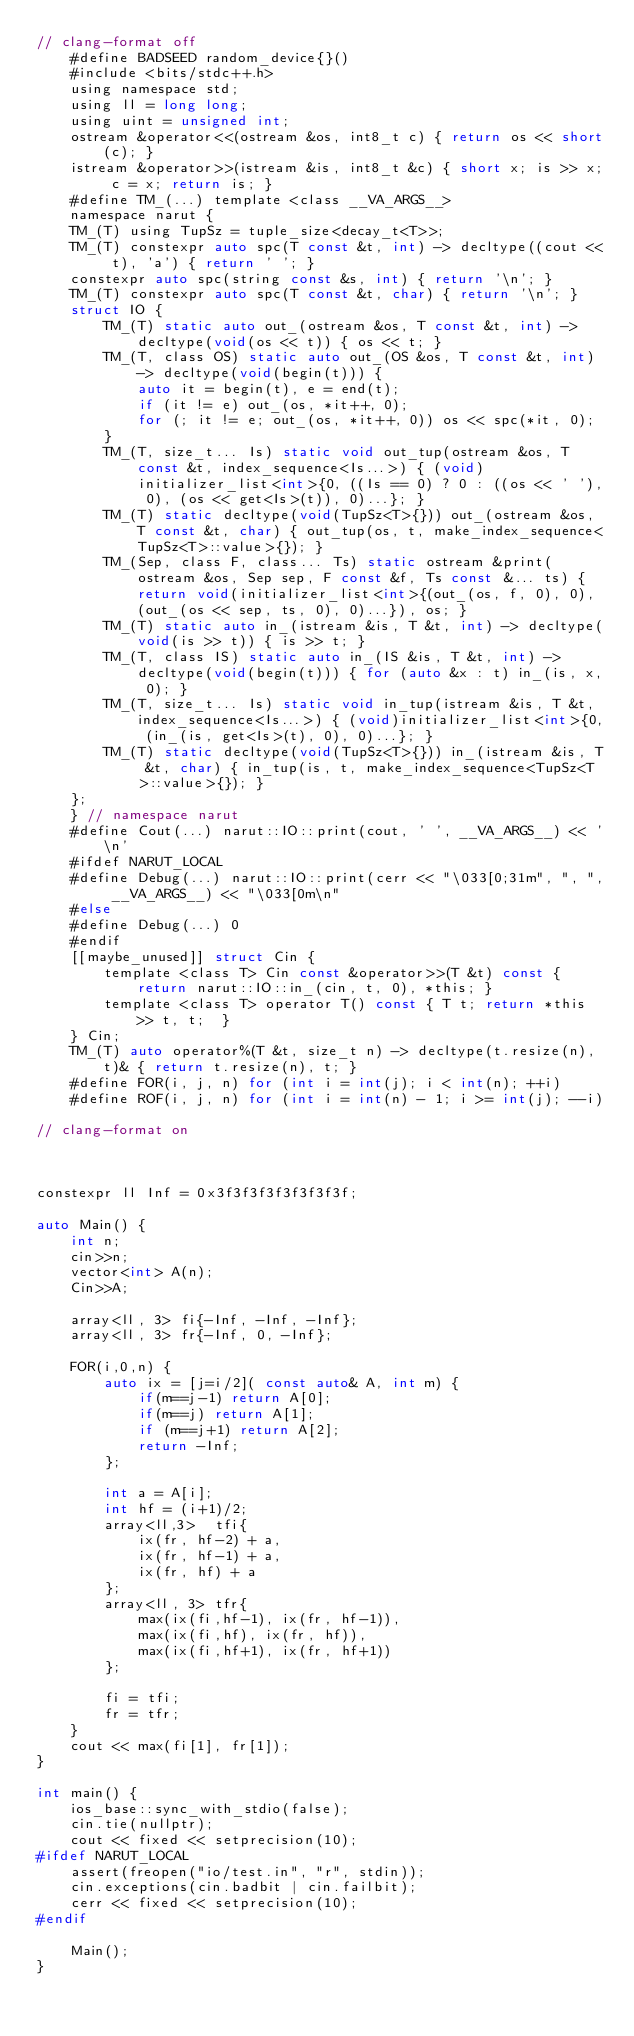Convert code to text. <code><loc_0><loc_0><loc_500><loc_500><_C_>// clang-format off
	#define BADSEED random_device{}()
	#include <bits/stdc++.h>
	using namespace std;
	using ll = long long;
	using uint = unsigned int;
	ostream &operator<<(ostream &os, int8_t c) { return os << short(c); }
	istream &operator>>(istream &is, int8_t &c) { short x; is >> x; c = x; return is; }
	#define TM_(...) template <class __VA_ARGS__>
	namespace narut {
	TM_(T) using TupSz = tuple_size<decay_t<T>>;
	TM_(T) constexpr auto spc(T const &t, int) -> decltype((cout << t), 'a') { return ' '; }
	constexpr auto spc(string const &s, int) { return '\n'; }
	TM_(T) constexpr auto spc(T const &t, char) { return '\n'; }
	struct IO {
		TM_(T) static auto out_(ostream &os, T const &t, int) -> decltype(void(os << t)) { os << t; }
		TM_(T, class OS) static auto out_(OS &os, T const &t, int) -> decltype(void(begin(t))) {
			auto it = begin(t), e = end(t);
			if (it != e) out_(os, *it++, 0);
			for (; it != e; out_(os, *it++, 0)) os << spc(*it, 0);
		}
		TM_(T, size_t... Is) static void out_tup(ostream &os, T const &t, index_sequence<Is...>) { (void)initializer_list<int>{0, ((Is == 0) ? 0 : ((os << ' '), 0), (os << get<Is>(t)), 0)...}; }
		TM_(T) static decltype(void(TupSz<T>{})) out_(ostream &os, T const &t, char) { out_tup(os, t, make_index_sequence<TupSz<T>::value>{}); }
		TM_(Sep, class F, class... Ts) static ostream &print(ostream &os, Sep sep, F const &f, Ts const &... ts) { return void(initializer_list<int>{(out_(os, f, 0), 0), (out_(os << sep, ts, 0), 0)...}), os; }
		TM_(T) static auto in_(istream &is, T &t, int) -> decltype(void(is >> t)) { is >> t; }
		TM_(T, class IS) static auto in_(IS &is, T &t, int) -> decltype(void(begin(t))) { for (auto &x : t) in_(is, x, 0); }
		TM_(T, size_t... Is) static void in_tup(istream &is, T &t, index_sequence<Is...>) { (void)initializer_list<int>{0, (in_(is, get<Is>(t), 0), 0)...}; }
		TM_(T) static decltype(void(TupSz<T>{})) in_(istream &is, T &t, char) { in_tup(is, t, make_index_sequence<TupSz<T>::value>{}); }
	};
	} // namespace narut
	#define Cout(...) narut::IO::print(cout, ' ', __VA_ARGS__) << '\n'
	#ifdef NARUT_LOCAL
	#define Debug(...) narut::IO::print(cerr << "\033[0;31m", ", ", __VA_ARGS__) << "\033[0m\n"
	#else
	#define Debug(...) 0
	#endif
	[[maybe_unused]] struct Cin {
		template <class T> Cin const &operator>>(T &t) const { return narut::IO::in_(cin, t, 0), *this; }
		template <class T> operator T() const { T t; return *this >> t, t;  }
	} Cin;
	TM_(T) auto operator%(T &t, size_t n) -> decltype(t.resize(n), t)& { return t.resize(n), t; }
	#define FOR(i, j, n) for (int i = int(j); i < int(n); ++i)
	#define ROF(i, j, n) for (int i = int(n) - 1; i >= int(j); --i)

// clang-format on



constexpr ll Inf = 0x3f3f3f3f3f3f3f3f;

auto Main() {
	int n;
	cin>>n;
	vector<int> A(n);
	Cin>>A;

	array<ll, 3> fi{-Inf, -Inf, -Inf};
	array<ll, 3> fr{-Inf, 0, -Inf};

	FOR(i,0,n) {
		auto ix = [j=i/2]( const auto& A, int m) {
			if(m==j-1) return A[0];
			if(m==j) return A[1];
			if (m==j+1) return A[2];
			return -Inf;
		};

		int a = A[i];
		int hf = (i+1)/2;
		array<ll,3>  tfi{
			ix(fr, hf-2) + a,
			ix(fr, hf-1) + a,
			ix(fr, hf) + a
		};
		array<ll, 3> tfr{
			max(ix(fi,hf-1), ix(fr, hf-1)),
			max(ix(fi,hf), ix(fr, hf)),
			max(ix(fi,hf+1), ix(fr, hf+1))
		};
		
		fi = tfi;
		fr = tfr;
	}
	cout << max(fi[1], fr[1]);
}

int main() {
	ios_base::sync_with_stdio(false);
	cin.tie(nullptr);
	cout << fixed << setprecision(10);
#ifdef NARUT_LOCAL
	assert(freopen("io/test.in", "r", stdin));
	cin.exceptions(cin.badbit | cin.failbit);
	cerr << fixed << setprecision(10);
#endif

	Main();
}
</code> 